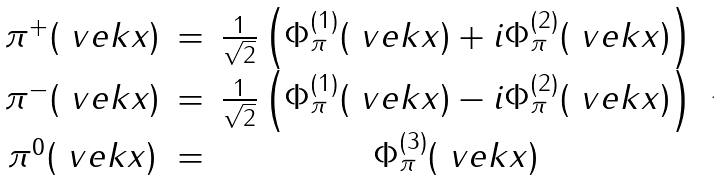<formula> <loc_0><loc_0><loc_500><loc_500>\begin{array} { c c c } \pi ^ { + } ( \ v e k { x } ) & = & \frac { 1 } { \sqrt { 2 } } \left ( \Phi _ { \pi } ^ { ( 1 ) } ( \ v e k { x } ) + i \Phi _ { \pi } ^ { ( 2 ) } ( \ v e k { x } ) \right ) \\ \pi ^ { - } ( \ v e k { x } ) & = & \frac { 1 } { \sqrt { 2 } } \left ( \Phi _ { \pi } ^ { ( 1 ) } ( \ v e k { x } ) - i \Phi _ { \pi } ^ { ( 2 ) } ( \ v e k { x } ) \right ) \\ \pi ^ { 0 } ( \ v e k { x } ) & = & \Phi _ { \pi } ^ { ( 3 ) } ( \ v e k { x } ) \end{array} \ .</formula> 